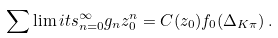<formula> <loc_0><loc_0><loc_500><loc_500>\sum \lim i t s _ { n = 0 } ^ { \infty } g _ { n } z _ { 0 } ^ { n } = C ( z _ { 0 } ) f _ { 0 } ( \Delta _ { K \pi } ) \, .</formula> 